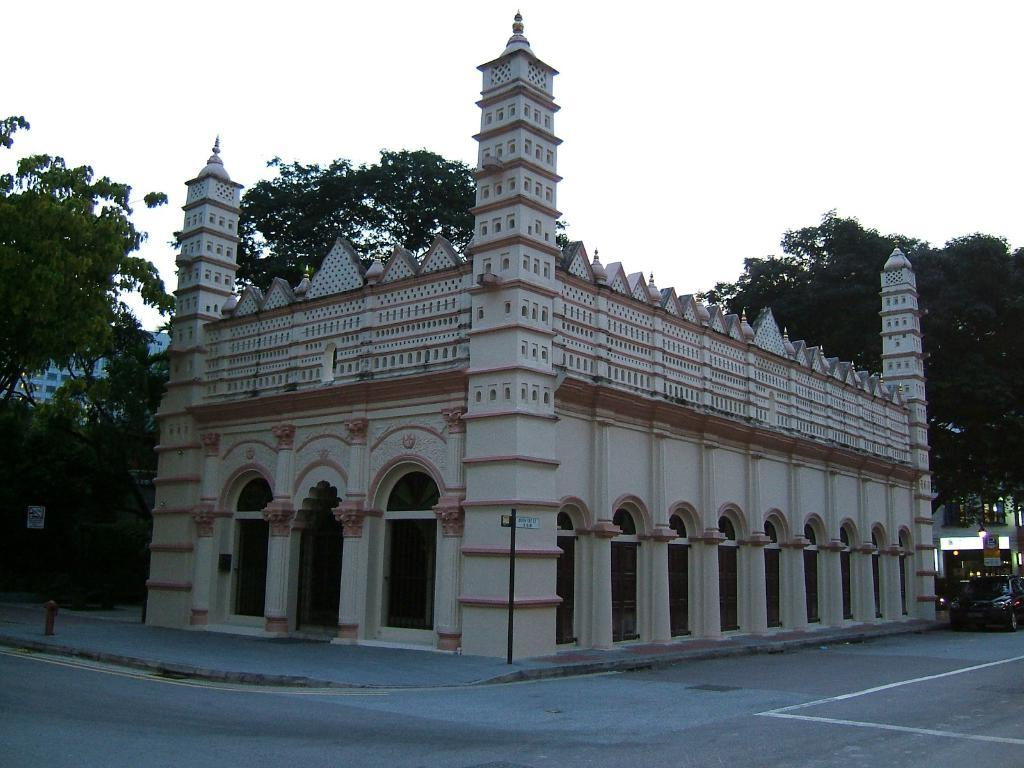What type of structures can be seen in the image? There are buildings in the image. What object is related to fire safety in the image? There is a hydrant in the image. What type of vegetation is present in the image? There are trees in the image. What mode of transportation can be seen on the road in the image? There is a motor vehicle on the road in the image. What type of informational or directional signs are present in the image? There are sign boards in the image. What part of the natural environment is visible in the image? The sky is visible in the image. What type of milk is being served in the hall in the image? There is no mention of milk or a hall in the image; it features buildings, a hydrant, trees, a motor vehicle, sign boards, and the sky. 